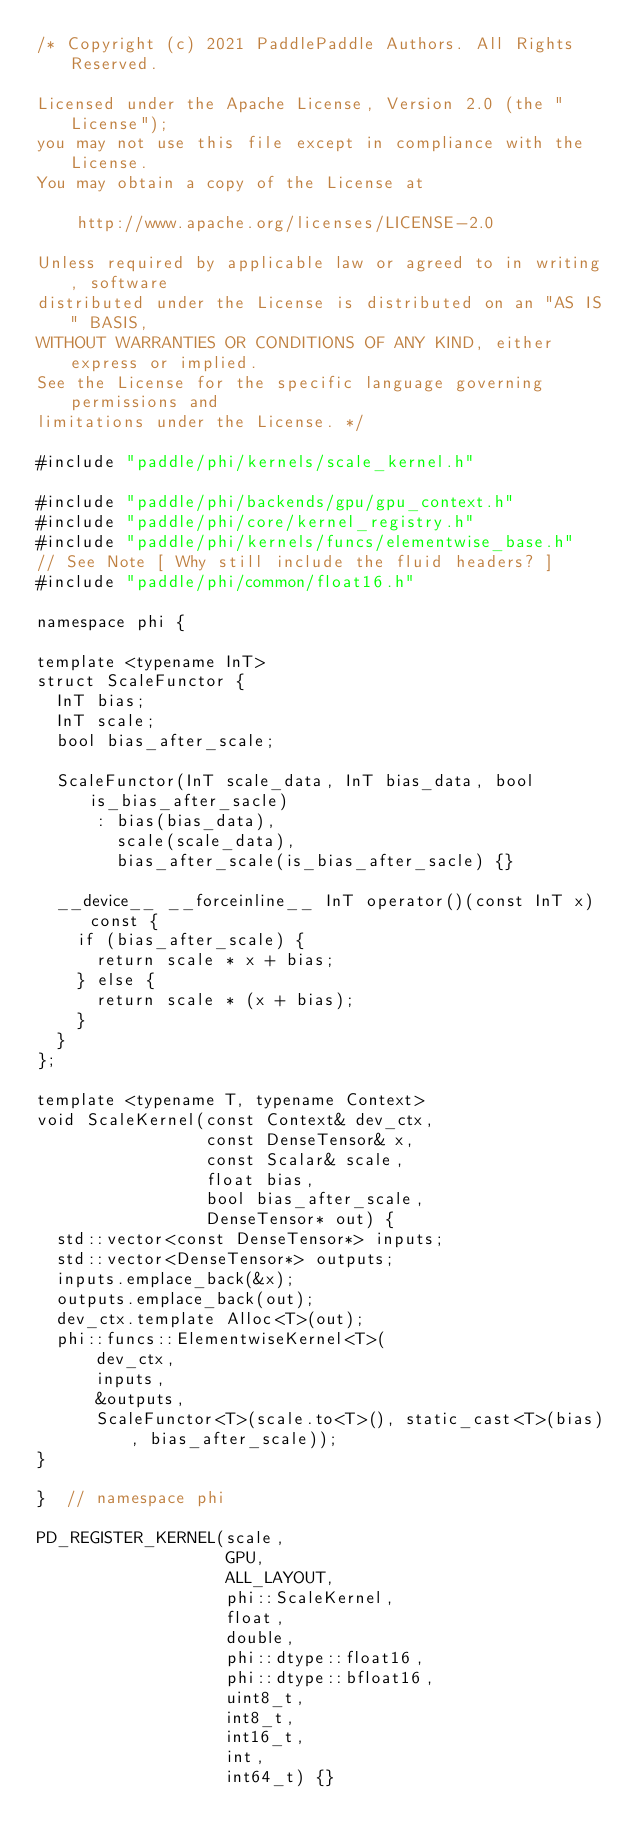Convert code to text. <code><loc_0><loc_0><loc_500><loc_500><_Cuda_>/* Copyright (c) 2021 PaddlePaddle Authors. All Rights Reserved.

Licensed under the Apache License, Version 2.0 (the "License");
you may not use this file except in compliance with the License.
You may obtain a copy of the License at

    http://www.apache.org/licenses/LICENSE-2.0

Unless required by applicable law or agreed to in writing, software
distributed under the License is distributed on an "AS IS" BASIS,
WITHOUT WARRANTIES OR CONDITIONS OF ANY KIND, either express or implied.
See the License for the specific language governing permissions and
limitations under the License. */

#include "paddle/phi/kernels/scale_kernel.h"

#include "paddle/phi/backends/gpu/gpu_context.h"
#include "paddle/phi/core/kernel_registry.h"
#include "paddle/phi/kernels/funcs/elementwise_base.h"
// See Note [ Why still include the fluid headers? ]
#include "paddle/phi/common/float16.h"

namespace phi {

template <typename InT>
struct ScaleFunctor {
  InT bias;
  InT scale;
  bool bias_after_scale;

  ScaleFunctor(InT scale_data, InT bias_data, bool is_bias_after_sacle)
      : bias(bias_data),
        scale(scale_data),
        bias_after_scale(is_bias_after_sacle) {}

  __device__ __forceinline__ InT operator()(const InT x) const {
    if (bias_after_scale) {
      return scale * x + bias;
    } else {
      return scale * (x + bias);
    }
  }
};

template <typename T, typename Context>
void ScaleKernel(const Context& dev_ctx,
                 const DenseTensor& x,
                 const Scalar& scale,
                 float bias,
                 bool bias_after_scale,
                 DenseTensor* out) {
  std::vector<const DenseTensor*> inputs;
  std::vector<DenseTensor*> outputs;
  inputs.emplace_back(&x);
  outputs.emplace_back(out);
  dev_ctx.template Alloc<T>(out);
  phi::funcs::ElementwiseKernel<T>(
      dev_ctx,
      inputs,
      &outputs,
      ScaleFunctor<T>(scale.to<T>(), static_cast<T>(bias), bias_after_scale));
}

}  // namespace phi

PD_REGISTER_KERNEL(scale,
                   GPU,
                   ALL_LAYOUT,
                   phi::ScaleKernel,
                   float,
                   double,
                   phi::dtype::float16,
                   phi::dtype::bfloat16,
                   uint8_t,
                   int8_t,
                   int16_t,
                   int,
                   int64_t) {}
</code> 